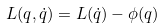Convert formula to latex. <formula><loc_0><loc_0><loc_500><loc_500>L ( q , \dot { q } ) = L ( \dot { q } ) - \phi ( q )</formula> 